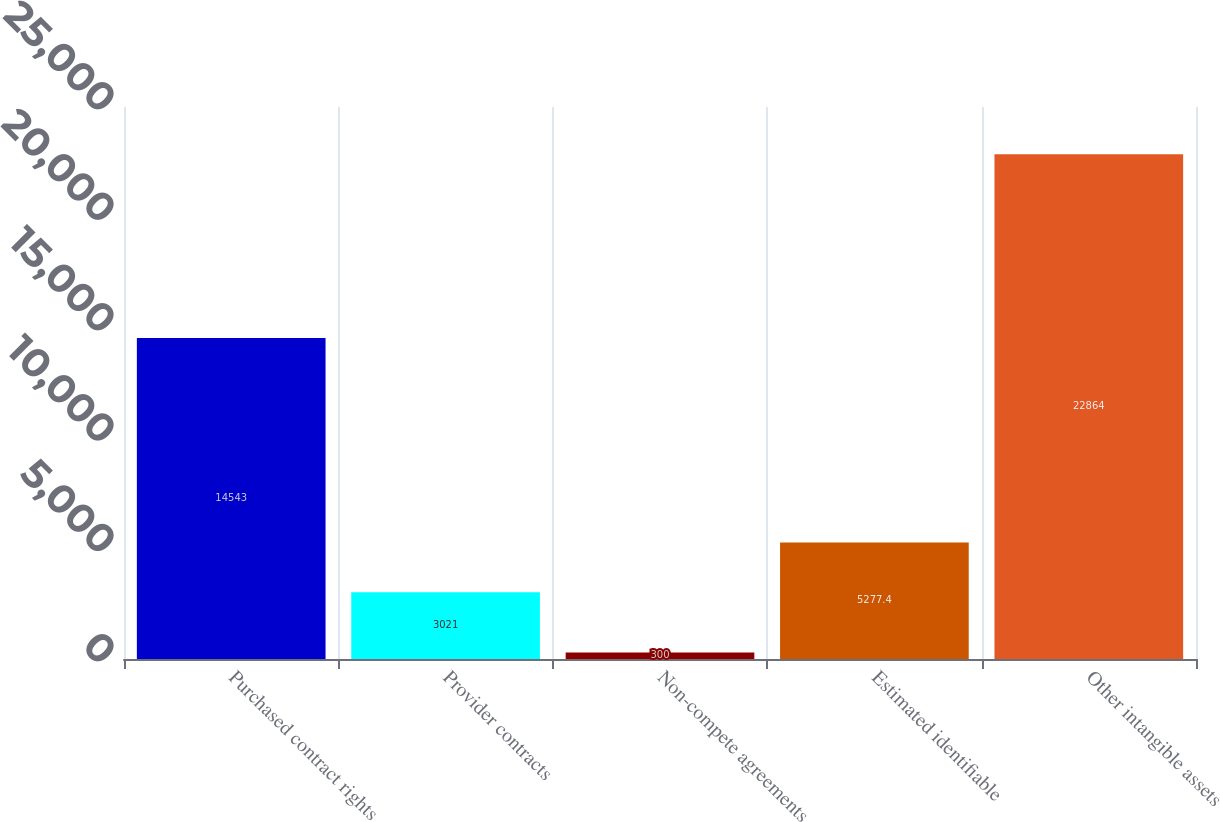Convert chart to OTSL. <chart><loc_0><loc_0><loc_500><loc_500><bar_chart><fcel>Purchased contract rights<fcel>Provider contracts<fcel>Non-compete agreements<fcel>Estimated identifiable<fcel>Other intangible assets<nl><fcel>14543<fcel>3021<fcel>300<fcel>5277.4<fcel>22864<nl></chart> 